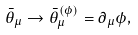Convert formula to latex. <formula><loc_0><loc_0><loc_500><loc_500>\bar { \theta } _ { \mu } \rightarrow \bar { \theta } _ { \mu } ^ { \left ( \phi \right ) } = \partial _ { \mu } \phi ,</formula> 